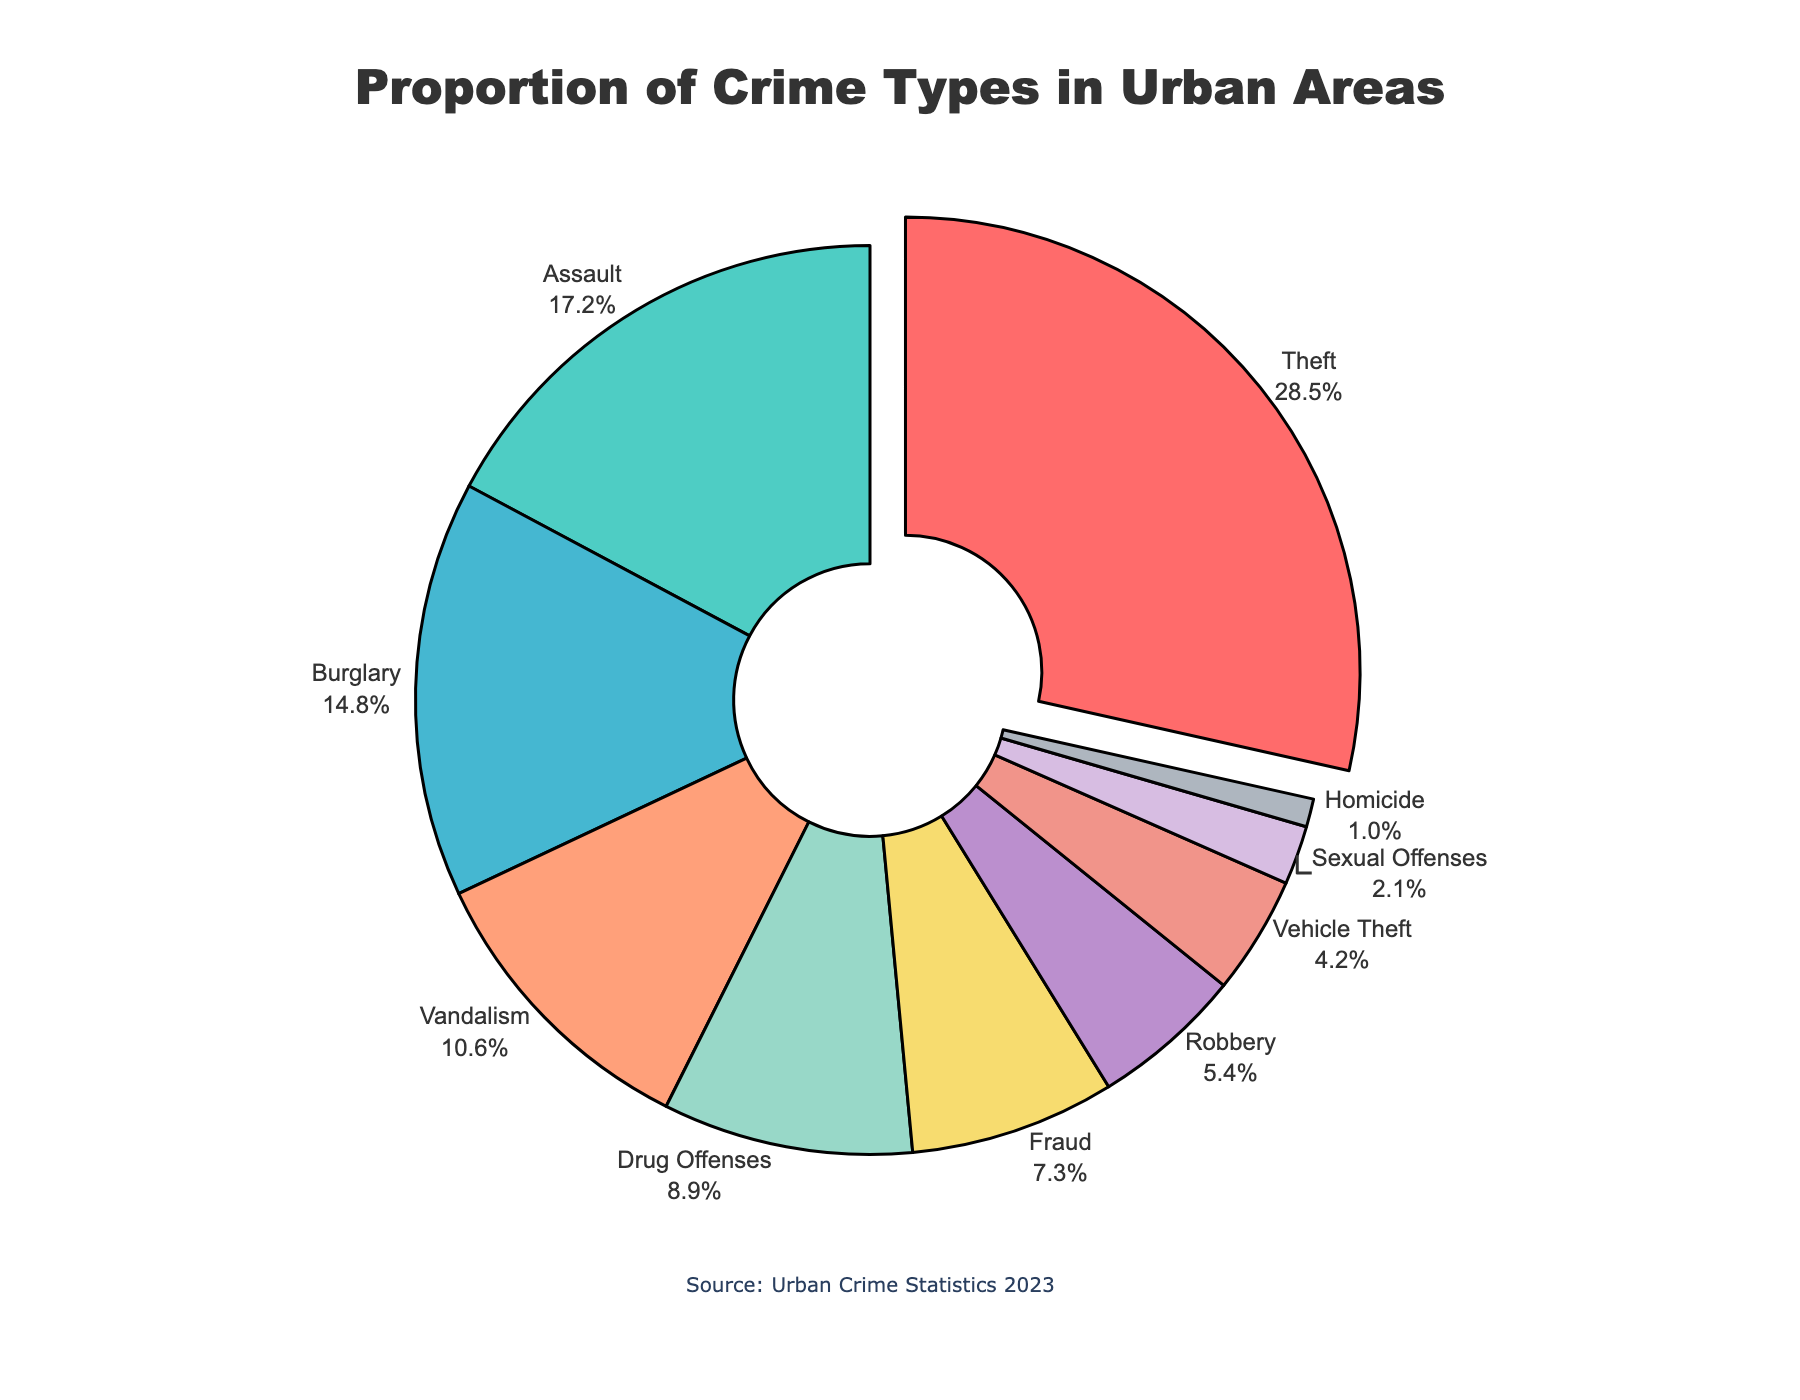Which crime type has the highest proportion? The crime type with the highest proportion will have the largest percentage on its respective pie chart segment, and it may also be visually emphasized or "pulled" out. Observing the chart, Theft has the largest segment, comprising 28.5% of the pie.
Answer: Theft How much larger is the proportion of Theft compared to Assault? To find out how much larger the proportion of Theft is compared to Assault, subtract the percentage of Assault from the percentage of Theft: 28.5% - 17.2% = 11.3%.
Answer: 11.3% Which crime types together make up more than 50% of the chart? To determine which crime types together exceed 50%, we start summing the largest percentages until we surpass 50%. Adding Theft (28.5%), Assault (17.2%), and Burglary (14.8%) gives us 60.5%, which is over 50%. Thus, Theft, Assault, and Burglary together exceed 50%.
Answer: Theft, Assault, Burglary What is the combined proportion of Vandalism and Fraud? Add the percentages of Vandalism (10.6%) and Fraud (7.3%): 10.6% + 7.3% = 17.9%.
Answer: 17.9% Is the proportion of Drug Offenses greater or less than the combined proportion of Robbery and Vehicle Theft? Calculate the combined proportion of Robbery (5.4%) and Vehicle Theft (4.2%): 5.4% + 4.2% = 9.6%. Compare this with the proportion of Drug Offenses (8.9%). Since 8.9% < 9.6%, Drug Offenses is less.
Answer: Less What percentage of crimes are categorized as Sexual Offenses or Homicide? Combine the percentages for Sexual Offenses (2.1%) and Homicide (1.0%): 2.1% + 1.0% = 3.1%.
Answer: 3.1% Which crime type has the smallest proportion, and what is its percentage? The crime type with the smallest segment represents the smallest proportion. Observing the chart, Homicide has the smallest segment, with a proportion of 1.0%.
Answer: Homicide, 1.0% What is the difference in proportion between the highest and lowest crime types reported? Subtract the percentage of the lowest crime type (Homicide, 1.0%) from the highest crime type (Theft, 28.5%): 28.5% - 1.0% = 27.5%.
Answer: 27.5% Which crime types are represented by segments in shades of blue, and what are their combined proportions? From the color scheme, the segments in shades of blue are likely Assault (17.2%) and Vehicle Theft (4.2%). Combine the proportions: 17.2% + 4.2% = 21.4%.
Answer: Assault, Vehicle Theft; 21.4% What is the total percentage of crimes not involving property (i.e., excluding Theft, Burglary, and Vehicle Theft)? First, calculate the combined percentage of property crimes: Theft (28.5%), Burglary (14.8%), and Vehicle Theft (4.2%): 28.5% + 14.8% + 4.2% = 47.5%. Subtract from 100%: 100% - 47.5% = 52.5%.
Answer: 52.5% 